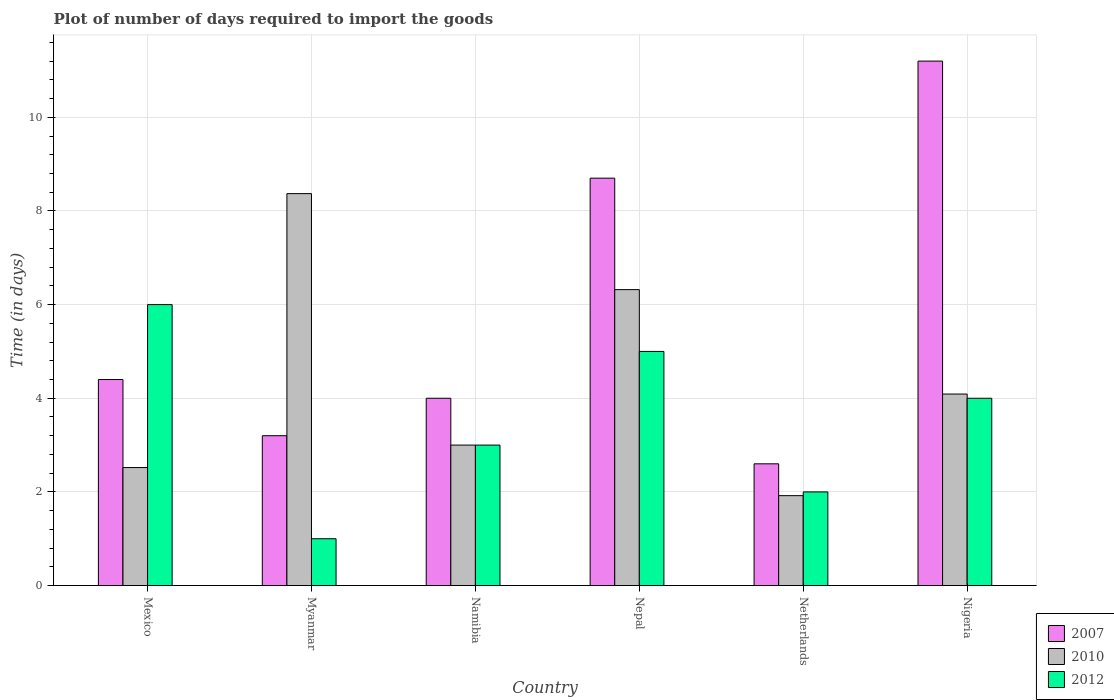How many groups of bars are there?
Keep it short and to the point. 6. Are the number of bars per tick equal to the number of legend labels?
Keep it short and to the point. Yes. How many bars are there on the 5th tick from the left?
Give a very brief answer. 3. How many bars are there on the 6th tick from the right?
Make the answer very short. 3. What is the label of the 3rd group of bars from the left?
Make the answer very short. Namibia. Across all countries, what is the minimum time required to import goods in 2007?
Your response must be concise. 2.6. In which country was the time required to import goods in 2007 maximum?
Provide a short and direct response. Nigeria. In which country was the time required to import goods in 2010 minimum?
Keep it short and to the point. Netherlands. What is the total time required to import goods in 2012 in the graph?
Ensure brevity in your answer.  21. What is the difference between the time required to import goods in 2010 in Nepal and that in Nigeria?
Your answer should be compact. 2.23. What is the difference between the time required to import goods in 2010 in Netherlands and the time required to import goods in 2007 in Mexico?
Ensure brevity in your answer.  -2.48. What is the average time required to import goods in 2010 per country?
Provide a short and direct response. 4.37. What is the difference between the time required to import goods of/in 2012 and time required to import goods of/in 2007 in Netherlands?
Provide a short and direct response. -0.6. Is the difference between the time required to import goods in 2012 in Mexico and Myanmar greater than the difference between the time required to import goods in 2007 in Mexico and Myanmar?
Your answer should be compact. Yes. What is the difference between the highest and the lowest time required to import goods in 2010?
Make the answer very short. 6.45. In how many countries, is the time required to import goods in 2012 greater than the average time required to import goods in 2012 taken over all countries?
Provide a short and direct response. 3. Is the sum of the time required to import goods in 2012 in Myanmar and Netherlands greater than the maximum time required to import goods in 2010 across all countries?
Offer a very short reply. No. What does the 3rd bar from the left in Mexico represents?
Make the answer very short. 2012. What does the 3rd bar from the right in Mexico represents?
Make the answer very short. 2007. Is it the case that in every country, the sum of the time required to import goods in 2012 and time required to import goods in 2010 is greater than the time required to import goods in 2007?
Keep it short and to the point. No. Are all the bars in the graph horizontal?
Ensure brevity in your answer.  No. How many countries are there in the graph?
Provide a short and direct response. 6. What is the difference between two consecutive major ticks on the Y-axis?
Ensure brevity in your answer.  2. Are the values on the major ticks of Y-axis written in scientific E-notation?
Ensure brevity in your answer.  No. Does the graph contain any zero values?
Offer a terse response. No. Does the graph contain grids?
Provide a succinct answer. Yes. What is the title of the graph?
Ensure brevity in your answer.  Plot of number of days required to import the goods. Does "1983" appear as one of the legend labels in the graph?
Ensure brevity in your answer.  No. What is the label or title of the Y-axis?
Your answer should be very brief. Time (in days). What is the Time (in days) in 2007 in Mexico?
Ensure brevity in your answer.  4.4. What is the Time (in days) in 2010 in Mexico?
Offer a very short reply. 2.52. What is the Time (in days) of 2012 in Mexico?
Offer a terse response. 6. What is the Time (in days) of 2010 in Myanmar?
Offer a very short reply. 8.37. What is the Time (in days) of 2010 in Namibia?
Offer a terse response. 3. What is the Time (in days) of 2012 in Namibia?
Your answer should be compact. 3. What is the Time (in days) in 2010 in Nepal?
Offer a very short reply. 6.32. What is the Time (in days) in 2012 in Nepal?
Keep it short and to the point. 5. What is the Time (in days) in 2007 in Netherlands?
Your response must be concise. 2.6. What is the Time (in days) of 2010 in Netherlands?
Your answer should be compact. 1.92. What is the Time (in days) in 2007 in Nigeria?
Ensure brevity in your answer.  11.2. What is the Time (in days) of 2010 in Nigeria?
Ensure brevity in your answer.  4.09. Across all countries, what is the maximum Time (in days) in 2010?
Your response must be concise. 8.37. Across all countries, what is the maximum Time (in days) in 2012?
Ensure brevity in your answer.  6. Across all countries, what is the minimum Time (in days) in 2007?
Your response must be concise. 2.6. Across all countries, what is the minimum Time (in days) of 2010?
Your answer should be very brief. 1.92. What is the total Time (in days) of 2007 in the graph?
Your answer should be very brief. 34.1. What is the total Time (in days) of 2010 in the graph?
Your answer should be very brief. 26.22. What is the difference between the Time (in days) of 2010 in Mexico and that in Myanmar?
Provide a succinct answer. -5.85. What is the difference between the Time (in days) in 2012 in Mexico and that in Myanmar?
Your answer should be compact. 5. What is the difference between the Time (in days) of 2010 in Mexico and that in Namibia?
Give a very brief answer. -0.48. What is the difference between the Time (in days) in 2012 in Mexico and that in Namibia?
Your answer should be compact. 3. What is the difference between the Time (in days) in 2010 in Mexico and that in Nepal?
Provide a short and direct response. -3.8. What is the difference between the Time (in days) of 2012 in Mexico and that in Nepal?
Provide a succinct answer. 1. What is the difference between the Time (in days) in 2007 in Mexico and that in Netherlands?
Your response must be concise. 1.8. What is the difference between the Time (in days) of 2010 in Mexico and that in Netherlands?
Your answer should be very brief. 0.6. What is the difference between the Time (in days) of 2012 in Mexico and that in Netherlands?
Make the answer very short. 4. What is the difference between the Time (in days) in 2010 in Mexico and that in Nigeria?
Provide a short and direct response. -1.57. What is the difference between the Time (in days) of 2012 in Mexico and that in Nigeria?
Offer a very short reply. 2. What is the difference between the Time (in days) in 2007 in Myanmar and that in Namibia?
Give a very brief answer. -0.8. What is the difference between the Time (in days) of 2010 in Myanmar and that in Namibia?
Offer a terse response. 5.37. What is the difference between the Time (in days) of 2010 in Myanmar and that in Nepal?
Offer a very short reply. 2.05. What is the difference between the Time (in days) of 2007 in Myanmar and that in Netherlands?
Your response must be concise. 0.6. What is the difference between the Time (in days) of 2010 in Myanmar and that in Netherlands?
Your answer should be very brief. 6.45. What is the difference between the Time (in days) of 2012 in Myanmar and that in Netherlands?
Make the answer very short. -1. What is the difference between the Time (in days) of 2010 in Myanmar and that in Nigeria?
Keep it short and to the point. 4.28. What is the difference between the Time (in days) in 2010 in Namibia and that in Nepal?
Your answer should be compact. -3.32. What is the difference between the Time (in days) of 2012 in Namibia and that in Nepal?
Make the answer very short. -2. What is the difference between the Time (in days) in 2007 in Namibia and that in Netherlands?
Offer a very short reply. 1.4. What is the difference between the Time (in days) in 2010 in Namibia and that in Netherlands?
Offer a very short reply. 1.08. What is the difference between the Time (in days) in 2012 in Namibia and that in Netherlands?
Give a very brief answer. 1. What is the difference between the Time (in days) in 2010 in Namibia and that in Nigeria?
Your response must be concise. -1.09. What is the difference between the Time (in days) in 2010 in Nepal and that in Netherlands?
Your answer should be very brief. 4.4. What is the difference between the Time (in days) of 2012 in Nepal and that in Netherlands?
Offer a very short reply. 3. What is the difference between the Time (in days) in 2010 in Nepal and that in Nigeria?
Offer a very short reply. 2.23. What is the difference between the Time (in days) of 2012 in Nepal and that in Nigeria?
Provide a short and direct response. 1. What is the difference between the Time (in days) in 2010 in Netherlands and that in Nigeria?
Your answer should be very brief. -2.17. What is the difference between the Time (in days) in 2007 in Mexico and the Time (in days) in 2010 in Myanmar?
Offer a very short reply. -3.97. What is the difference between the Time (in days) in 2007 in Mexico and the Time (in days) in 2012 in Myanmar?
Make the answer very short. 3.4. What is the difference between the Time (in days) in 2010 in Mexico and the Time (in days) in 2012 in Myanmar?
Your response must be concise. 1.52. What is the difference between the Time (in days) in 2007 in Mexico and the Time (in days) in 2010 in Namibia?
Ensure brevity in your answer.  1.4. What is the difference between the Time (in days) of 2010 in Mexico and the Time (in days) of 2012 in Namibia?
Your answer should be compact. -0.48. What is the difference between the Time (in days) of 2007 in Mexico and the Time (in days) of 2010 in Nepal?
Your response must be concise. -1.92. What is the difference between the Time (in days) of 2007 in Mexico and the Time (in days) of 2012 in Nepal?
Make the answer very short. -0.6. What is the difference between the Time (in days) of 2010 in Mexico and the Time (in days) of 2012 in Nepal?
Keep it short and to the point. -2.48. What is the difference between the Time (in days) in 2007 in Mexico and the Time (in days) in 2010 in Netherlands?
Ensure brevity in your answer.  2.48. What is the difference between the Time (in days) of 2007 in Mexico and the Time (in days) of 2012 in Netherlands?
Provide a succinct answer. 2.4. What is the difference between the Time (in days) in 2010 in Mexico and the Time (in days) in 2012 in Netherlands?
Ensure brevity in your answer.  0.52. What is the difference between the Time (in days) of 2007 in Mexico and the Time (in days) of 2010 in Nigeria?
Give a very brief answer. 0.31. What is the difference between the Time (in days) of 2007 in Mexico and the Time (in days) of 2012 in Nigeria?
Offer a very short reply. 0.4. What is the difference between the Time (in days) in 2010 in Mexico and the Time (in days) in 2012 in Nigeria?
Provide a succinct answer. -1.48. What is the difference between the Time (in days) in 2007 in Myanmar and the Time (in days) in 2012 in Namibia?
Give a very brief answer. 0.2. What is the difference between the Time (in days) in 2010 in Myanmar and the Time (in days) in 2012 in Namibia?
Offer a terse response. 5.37. What is the difference between the Time (in days) in 2007 in Myanmar and the Time (in days) in 2010 in Nepal?
Offer a very short reply. -3.12. What is the difference between the Time (in days) in 2007 in Myanmar and the Time (in days) in 2012 in Nepal?
Provide a succinct answer. -1.8. What is the difference between the Time (in days) in 2010 in Myanmar and the Time (in days) in 2012 in Nepal?
Your answer should be very brief. 3.37. What is the difference between the Time (in days) of 2007 in Myanmar and the Time (in days) of 2010 in Netherlands?
Offer a very short reply. 1.28. What is the difference between the Time (in days) in 2010 in Myanmar and the Time (in days) in 2012 in Netherlands?
Your response must be concise. 6.37. What is the difference between the Time (in days) of 2007 in Myanmar and the Time (in days) of 2010 in Nigeria?
Provide a short and direct response. -0.89. What is the difference between the Time (in days) of 2010 in Myanmar and the Time (in days) of 2012 in Nigeria?
Your answer should be compact. 4.37. What is the difference between the Time (in days) in 2007 in Namibia and the Time (in days) in 2010 in Nepal?
Your answer should be compact. -2.32. What is the difference between the Time (in days) in 2010 in Namibia and the Time (in days) in 2012 in Nepal?
Your answer should be compact. -2. What is the difference between the Time (in days) of 2007 in Namibia and the Time (in days) of 2010 in Netherlands?
Offer a very short reply. 2.08. What is the difference between the Time (in days) in 2007 in Namibia and the Time (in days) in 2012 in Netherlands?
Offer a very short reply. 2. What is the difference between the Time (in days) in 2010 in Namibia and the Time (in days) in 2012 in Netherlands?
Your answer should be compact. 1. What is the difference between the Time (in days) in 2007 in Namibia and the Time (in days) in 2010 in Nigeria?
Provide a succinct answer. -0.09. What is the difference between the Time (in days) of 2007 in Namibia and the Time (in days) of 2012 in Nigeria?
Your answer should be very brief. 0. What is the difference between the Time (in days) of 2010 in Namibia and the Time (in days) of 2012 in Nigeria?
Your answer should be compact. -1. What is the difference between the Time (in days) in 2007 in Nepal and the Time (in days) in 2010 in Netherlands?
Give a very brief answer. 6.78. What is the difference between the Time (in days) of 2007 in Nepal and the Time (in days) of 2012 in Netherlands?
Make the answer very short. 6.7. What is the difference between the Time (in days) in 2010 in Nepal and the Time (in days) in 2012 in Netherlands?
Provide a succinct answer. 4.32. What is the difference between the Time (in days) of 2007 in Nepal and the Time (in days) of 2010 in Nigeria?
Provide a succinct answer. 4.61. What is the difference between the Time (in days) of 2007 in Nepal and the Time (in days) of 2012 in Nigeria?
Offer a very short reply. 4.7. What is the difference between the Time (in days) in 2010 in Nepal and the Time (in days) in 2012 in Nigeria?
Offer a terse response. 2.32. What is the difference between the Time (in days) of 2007 in Netherlands and the Time (in days) of 2010 in Nigeria?
Provide a short and direct response. -1.49. What is the difference between the Time (in days) of 2007 in Netherlands and the Time (in days) of 2012 in Nigeria?
Give a very brief answer. -1.4. What is the difference between the Time (in days) in 2010 in Netherlands and the Time (in days) in 2012 in Nigeria?
Keep it short and to the point. -2.08. What is the average Time (in days) of 2007 per country?
Offer a very short reply. 5.68. What is the average Time (in days) of 2010 per country?
Give a very brief answer. 4.37. What is the average Time (in days) of 2012 per country?
Your answer should be very brief. 3.5. What is the difference between the Time (in days) of 2007 and Time (in days) of 2010 in Mexico?
Give a very brief answer. 1.88. What is the difference between the Time (in days) in 2010 and Time (in days) in 2012 in Mexico?
Your answer should be very brief. -3.48. What is the difference between the Time (in days) of 2007 and Time (in days) of 2010 in Myanmar?
Your response must be concise. -5.17. What is the difference between the Time (in days) of 2010 and Time (in days) of 2012 in Myanmar?
Your answer should be compact. 7.37. What is the difference between the Time (in days) of 2007 and Time (in days) of 2010 in Namibia?
Provide a succinct answer. 1. What is the difference between the Time (in days) of 2007 and Time (in days) of 2012 in Namibia?
Make the answer very short. 1. What is the difference between the Time (in days) in 2007 and Time (in days) in 2010 in Nepal?
Give a very brief answer. 2.38. What is the difference between the Time (in days) in 2007 and Time (in days) in 2012 in Nepal?
Your answer should be compact. 3.7. What is the difference between the Time (in days) in 2010 and Time (in days) in 2012 in Nepal?
Your response must be concise. 1.32. What is the difference between the Time (in days) of 2007 and Time (in days) of 2010 in Netherlands?
Make the answer very short. 0.68. What is the difference between the Time (in days) of 2007 and Time (in days) of 2012 in Netherlands?
Your answer should be compact. 0.6. What is the difference between the Time (in days) in 2010 and Time (in days) in 2012 in Netherlands?
Offer a very short reply. -0.08. What is the difference between the Time (in days) in 2007 and Time (in days) in 2010 in Nigeria?
Your answer should be compact. 7.11. What is the difference between the Time (in days) of 2007 and Time (in days) of 2012 in Nigeria?
Ensure brevity in your answer.  7.2. What is the difference between the Time (in days) in 2010 and Time (in days) in 2012 in Nigeria?
Your answer should be very brief. 0.09. What is the ratio of the Time (in days) of 2007 in Mexico to that in Myanmar?
Make the answer very short. 1.38. What is the ratio of the Time (in days) of 2010 in Mexico to that in Myanmar?
Provide a succinct answer. 0.3. What is the ratio of the Time (in days) of 2012 in Mexico to that in Myanmar?
Give a very brief answer. 6. What is the ratio of the Time (in days) in 2010 in Mexico to that in Namibia?
Your answer should be compact. 0.84. What is the ratio of the Time (in days) of 2012 in Mexico to that in Namibia?
Ensure brevity in your answer.  2. What is the ratio of the Time (in days) of 2007 in Mexico to that in Nepal?
Ensure brevity in your answer.  0.51. What is the ratio of the Time (in days) of 2010 in Mexico to that in Nepal?
Keep it short and to the point. 0.4. What is the ratio of the Time (in days) in 2012 in Mexico to that in Nepal?
Provide a short and direct response. 1.2. What is the ratio of the Time (in days) of 2007 in Mexico to that in Netherlands?
Make the answer very short. 1.69. What is the ratio of the Time (in days) in 2010 in Mexico to that in Netherlands?
Give a very brief answer. 1.31. What is the ratio of the Time (in days) in 2012 in Mexico to that in Netherlands?
Give a very brief answer. 3. What is the ratio of the Time (in days) of 2007 in Mexico to that in Nigeria?
Offer a terse response. 0.39. What is the ratio of the Time (in days) in 2010 in Mexico to that in Nigeria?
Offer a very short reply. 0.62. What is the ratio of the Time (in days) in 2007 in Myanmar to that in Namibia?
Keep it short and to the point. 0.8. What is the ratio of the Time (in days) of 2010 in Myanmar to that in Namibia?
Your answer should be very brief. 2.79. What is the ratio of the Time (in days) in 2007 in Myanmar to that in Nepal?
Provide a short and direct response. 0.37. What is the ratio of the Time (in days) in 2010 in Myanmar to that in Nepal?
Provide a short and direct response. 1.32. What is the ratio of the Time (in days) in 2007 in Myanmar to that in Netherlands?
Give a very brief answer. 1.23. What is the ratio of the Time (in days) of 2010 in Myanmar to that in Netherlands?
Your answer should be compact. 4.36. What is the ratio of the Time (in days) of 2012 in Myanmar to that in Netherlands?
Offer a very short reply. 0.5. What is the ratio of the Time (in days) in 2007 in Myanmar to that in Nigeria?
Your response must be concise. 0.29. What is the ratio of the Time (in days) of 2010 in Myanmar to that in Nigeria?
Give a very brief answer. 2.05. What is the ratio of the Time (in days) in 2012 in Myanmar to that in Nigeria?
Ensure brevity in your answer.  0.25. What is the ratio of the Time (in days) of 2007 in Namibia to that in Nepal?
Offer a very short reply. 0.46. What is the ratio of the Time (in days) of 2010 in Namibia to that in Nepal?
Your answer should be compact. 0.47. What is the ratio of the Time (in days) of 2007 in Namibia to that in Netherlands?
Offer a very short reply. 1.54. What is the ratio of the Time (in days) of 2010 in Namibia to that in Netherlands?
Provide a succinct answer. 1.56. What is the ratio of the Time (in days) in 2007 in Namibia to that in Nigeria?
Provide a short and direct response. 0.36. What is the ratio of the Time (in days) of 2010 in Namibia to that in Nigeria?
Make the answer very short. 0.73. What is the ratio of the Time (in days) in 2007 in Nepal to that in Netherlands?
Offer a terse response. 3.35. What is the ratio of the Time (in days) in 2010 in Nepal to that in Netherlands?
Make the answer very short. 3.29. What is the ratio of the Time (in days) of 2012 in Nepal to that in Netherlands?
Provide a succinct answer. 2.5. What is the ratio of the Time (in days) in 2007 in Nepal to that in Nigeria?
Provide a succinct answer. 0.78. What is the ratio of the Time (in days) of 2010 in Nepal to that in Nigeria?
Ensure brevity in your answer.  1.55. What is the ratio of the Time (in days) in 2007 in Netherlands to that in Nigeria?
Offer a very short reply. 0.23. What is the ratio of the Time (in days) of 2010 in Netherlands to that in Nigeria?
Give a very brief answer. 0.47. What is the difference between the highest and the second highest Time (in days) in 2010?
Give a very brief answer. 2.05. What is the difference between the highest and the second highest Time (in days) of 2012?
Your answer should be compact. 1. What is the difference between the highest and the lowest Time (in days) in 2007?
Keep it short and to the point. 8.6. What is the difference between the highest and the lowest Time (in days) in 2010?
Ensure brevity in your answer.  6.45. 